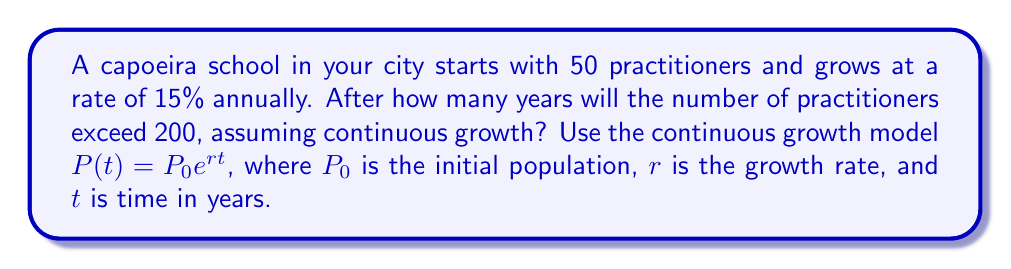Can you solve this math problem? Let's approach this step-by-step:

1) We're using the continuous growth model: $P(t) = P_0e^{rt}$

2) We know:
   $P_0 = 50$ (initial population)
   $r = 0.15$ (15% annual growth rate)
   We want to find $t$ when $P(t) > 200$

3) Let's set up the equation:
   $200 = 50e^{0.15t}$

4) Divide both sides by 50:
   $4 = e^{0.15t}$

5) Take the natural log of both sides:
   $\ln(4) = 0.15t$

6) Solve for $t$:
   $t = \frac{\ln(4)}{0.15}$

7) Calculate:
   $t = \frac{1.3862943611198906}{0.15} \approx 9.24196$

8) Since we can't have a fractional year in this context, we need to round up to the next whole year.

Therefore, the number of practitioners will exceed 200 after 10 years.
Answer: 10 years 